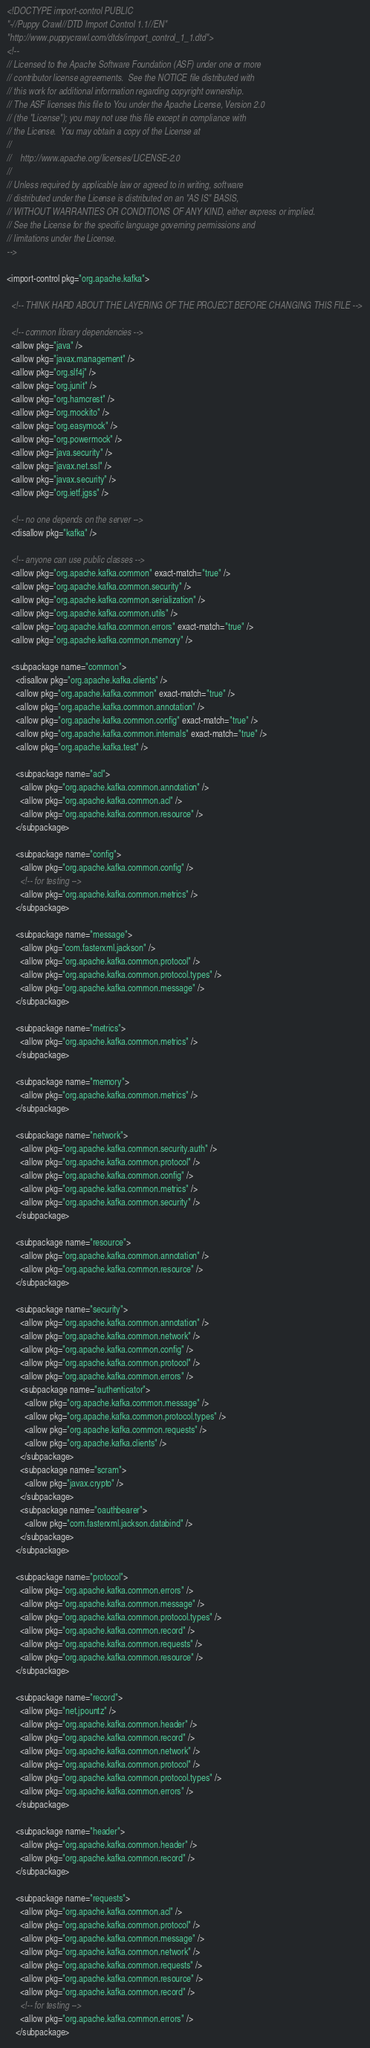<code> <loc_0><loc_0><loc_500><loc_500><_XML_><!DOCTYPE import-control PUBLIC
"-//Puppy Crawl//DTD Import Control 1.1//EN"
"http://www.puppycrawl.com/dtds/import_control_1_1.dtd">
<!--
// Licensed to the Apache Software Foundation (ASF) under one or more
// contributor license agreements.  See the NOTICE file distributed with
// this work for additional information regarding copyright ownership.
// The ASF licenses this file to You under the Apache License, Version 2.0
// (the "License"); you may not use this file except in compliance with
// the License.  You may obtain a copy of the License at
//
//    http://www.apache.org/licenses/LICENSE-2.0
//
// Unless required by applicable law or agreed to in writing, software
// distributed under the License is distributed on an "AS IS" BASIS,
// WITHOUT WARRANTIES OR CONDITIONS OF ANY KIND, either express or implied.
// See the License for the specific language governing permissions and
// limitations under the License.
-->

<import-control pkg="org.apache.kafka">

  <!-- THINK HARD ABOUT THE LAYERING OF THE PROJECT BEFORE CHANGING THIS FILE -->

  <!-- common library dependencies -->
  <allow pkg="java" />
  <allow pkg="javax.management" />
  <allow pkg="org.slf4j" />
  <allow pkg="org.junit" />
  <allow pkg="org.hamcrest" />
  <allow pkg="org.mockito" />
  <allow pkg="org.easymock" />
  <allow pkg="org.powermock" />
  <allow pkg="java.security" />
  <allow pkg="javax.net.ssl" />
  <allow pkg="javax.security" />
  <allow pkg="org.ietf.jgss" />

  <!-- no one depends on the server -->
  <disallow pkg="kafka" />

  <!-- anyone can use public classes -->
  <allow pkg="org.apache.kafka.common" exact-match="true" />
  <allow pkg="org.apache.kafka.common.security" />
  <allow pkg="org.apache.kafka.common.serialization" />
  <allow pkg="org.apache.kafka.common.utils" />
  <allow pkg="org.apache.kafka.common.errors" exact-match="true" />
  <allow pkg="org.apache.kafka.common.memory" />

  <subpackage name="common">
    <disallow pkg="org.apache.kafka.clients" />
    <allow pkg="org.apache.kafka.common" exact-match="true" />
    <allow pkg="org.apache.kafka.common.annotation" />
    <allow pkg="org.apache.kafka.common.config" exact-match="true" />
    <allow pkg="org.apache.kafka.common.internals" exact-match="true" />
    <allow pkg="org.apache.kafka.test" />

    <subpackage name="acl">
      <allow pkg="org.apache.kafka.common.annotation" />
      <allow pkg="org.apache.kafka.common.acl" />
      <allow pkg="org.apache.kafka.common.resource" />
    </subpackage>

    <subpackage name="config">
      <allow pkg="org.apache.kafka.common.config" />
      <!-- for testing -->
      <allow pkg="org.apache.kafka.common.metrics" />
    </subpackage>

    <subpackage name="message">
      <allow pkg="com.fasterxml.jackson" />
      <allow pkg="org.apache.kafka.common.protocol" />
      <allow pkg="org.apache.kafka.common.protocol.types" />
      <allow pkg="org.apache.kafka.common.message" />
    </subpackage>

    <subpackage name="metrics">
      <allow pkg="org.apache.kafka.common.metrics" />
    </subpackage>

    <subpackage name="memory">
      <allow pkg="org.apache.kafka.common.metrics" />
    </subpackage>

    <subpackage name="network">
      <allow pkg="org.apache.kafka.common.security.auth" />
      <allow pkg="org.apache.kafka.common.protocol" />
      <allow pkg="org.apache.kafka.common.config" />
      <allow pkg="org.apache.kafka.common.metrics" />
      <allow pkg="org.apache.kafka.common.security" />
    </subpackage>

    <subpackage name="resource">
      <allow pkg="org.apache.kafka.common.annotation" />
      <allow pkg="org.apache.kafka.common.resource" />
    </subpackage>

    <subpackage name="security">
      <allow pkg="org.apache.kafka.common.annotation" />
      <allow pkg="org.apache.kafka.common.network" />
      <allow pkg="org.apache.kafka.common.config" />
      <allow pkg="org.apache.kafka.common.protocol" />
      <allow pkg="org.apache.kafka.common.errors" />
      <subpackage name="authenticator">
        <allow pkg="org.apache.kafka.common.message" />
        <allow pkg="org.apache.kafka.common.protocol.types" />
        <allow pkg="org.apache.kafka.common.requests" />
        <allow pkg="org.apache.kafka.clients" />
      </subpackage>
      <subpackage name="scram">
        <allow pkg="javax.crypto" />
      </subpackage>
      <subpackage name="oauthbearer">
        <allow pkg="com.fasterxml.jackson.databind" />
      </subpackage>
    </subpackage>

    <subpackage name="protocol">
      <allow pkg="org.apache.kafka.common.errors" />
      <allow pkg="org.apache.kafka.common.message" />
      <allow pkg="org.apache.kafka.common.protocol.types" />
      <allow pkg="org.apache.kafka.common.record" />
      <allow pkg="org.apache.kafka.common.requests" />
      <allow pkg="org.apache.kafka.common.resource" />
    </subpackage>

    <subpackage name="record">
      <allow pkg="net.jpountz" />
      <allow pkg="org.apache.kafka.common.header" />
      <allow pkg="org.apache.kafka.common.record" />
      <allow pkg="org.apache.kafka.common.network" />
      <allow pkg="org.apache.kafka.common.protocol" />
      <allow pkg="org.apache.kafka.common.protocol.types" />
      <allow pkg="org.apache.kafka.common.errors" />
    </subpackage>

    <subpackage name="header">
      <allow pkg="org.apache.kafka.common.header" />
      <allow pkg="org.apache.kafka.common.record" />
    </subpackage>

    <subpackage name="requests">
      <allow pkg="org.apache.kafka.common.acl" />
      <allow pkg="org.apache.kafka.common.protocol" />
      <allow pkg="org.apache.kafka.common.message" />
      <allow pkg="org.apache.kafka.common.network" />
      <allow pkg="org.apache.kafka.common.requests" />
      <allow pkg="org.apache.kafka.common.resource" />
      <allow pkg="org.apache.kafka.common.record" />
      <!-- for testing -->
      <allow pkg="org.apache.kafka.common.errors" />
    </subpackage>
</code> 